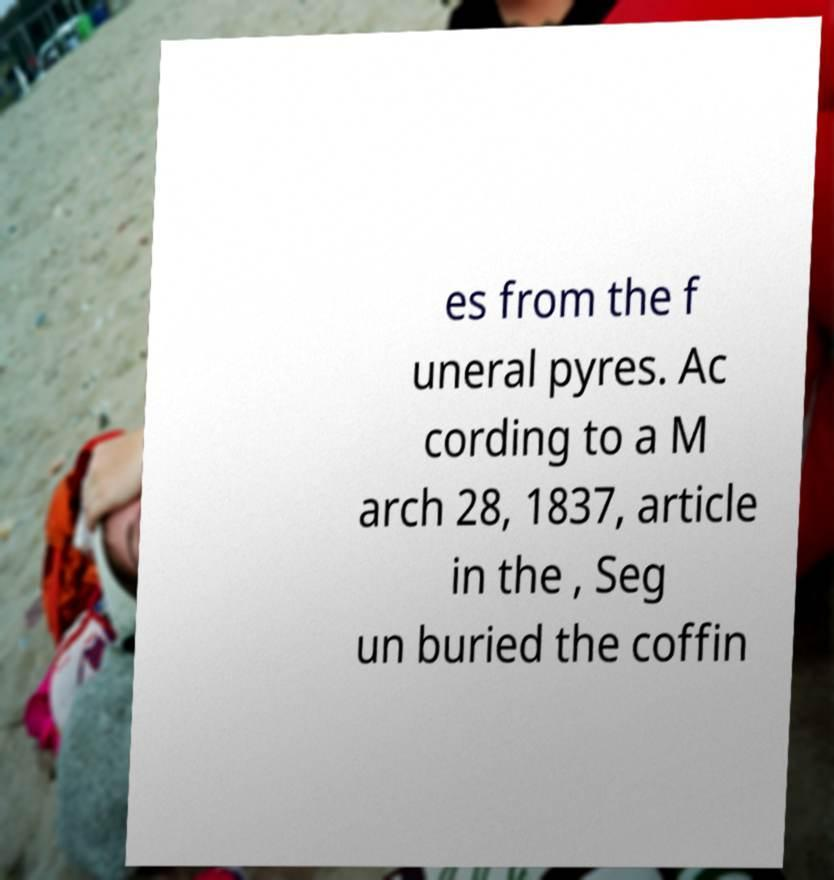Could you extract and type out the text from this image? es from the f uneral pyres. Ac cording to a M arch 28, 1837, article in the , Seg un buried the coffin 